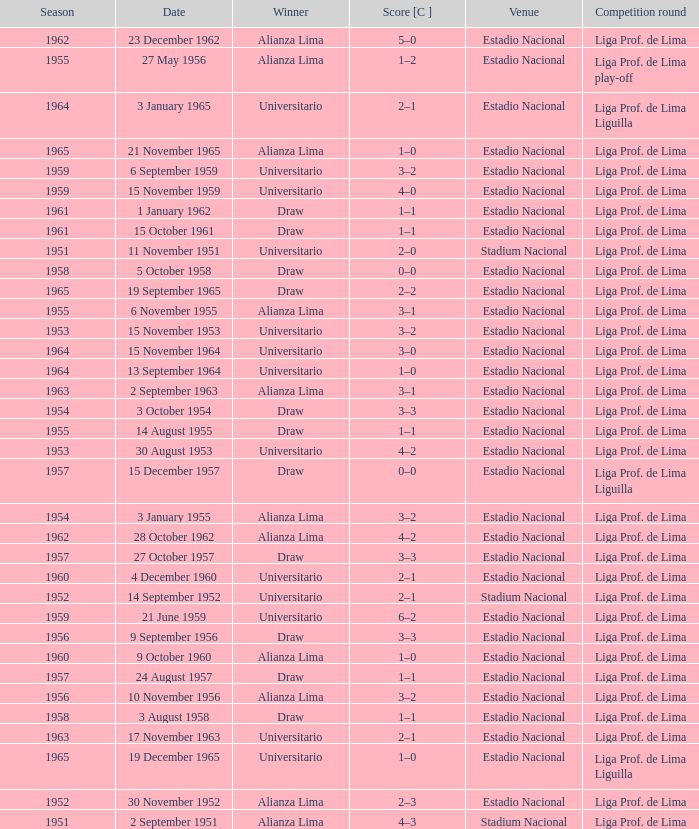Who was the winner on 15 December 1957? Draw. 